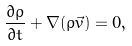<formula> <loc_0><loc_0><loc_500><loc_500>\frac { \partial \rho } { \partial t } + \nabla ( \rho \vec { v } ) = 0 ,</formula> 